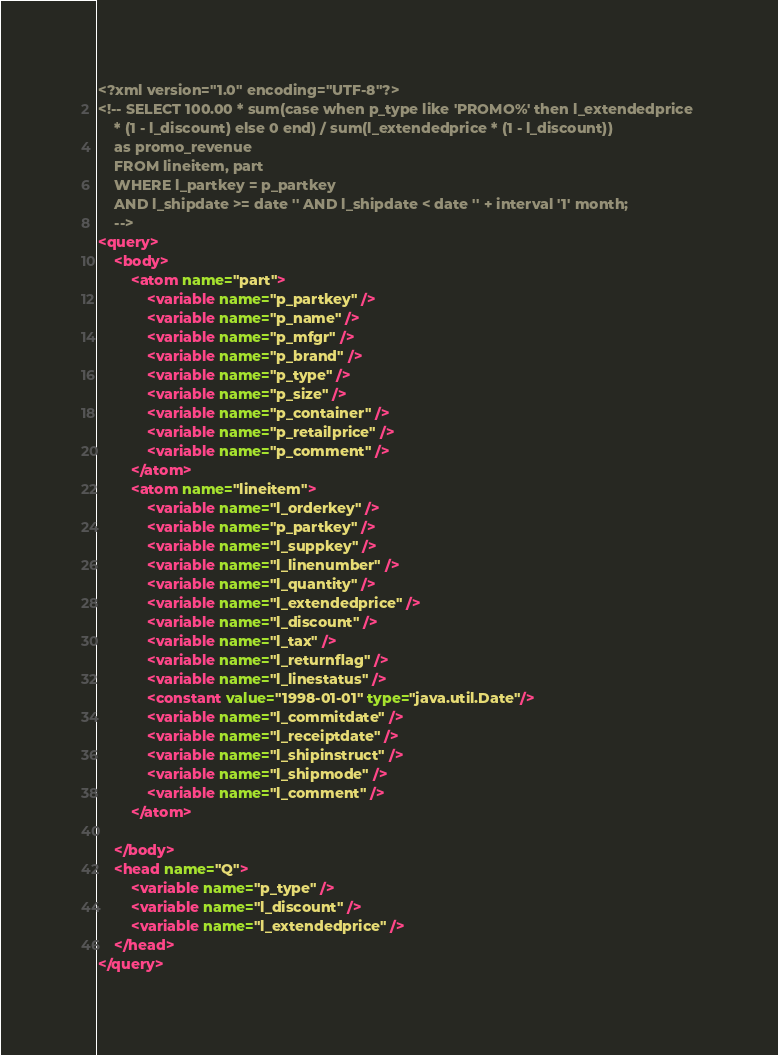<code> <loc_0><loc_0><loc_500><loc_500><_XML_><?xml version="1.0" encoding="UTF-8"?>
<!-- SELECT 100.00 * sum(case when p_type like 'PROMO%' then l_extendedprice 
	* (1 - l_discount) else 0 end) / sum(l_extendedprice * (1 - l_discount)) 
	as promo_revenue 
	FROM lineitem, part 
	WHERE l_partkey = p_partkey
	AND l_shipdate >= date '' AND l_shipdate < date '' + interval '1' month;
	-->
<query>
	<body>
		<atom name="part">
			<variable name="p_partkey" />
			<variable name="p_name" />
			<variable name="p_mfgr" />
			<variable name="p_brand" />
			<variable name="p_type" />
			<variable name="p_size" />
			<variable name="p_container" />
			<variable name="p_retailprice" />
			<variable name="p_comment" />
		</atom>
		<atom name="lineitem">
			<variable name="l_orderkey" />
			<variable name="p_partkey" />
			<variable name="l_suppkey" />
			<variable name="l_linenumber" />
			<variable name="l_quantity" />
			<variable name="l_extendedprice" />
			<variable name="l_discount" />
			<variable name="l_tax" />
			<variable name="l_returnflag" />
			<variable name="l_linestatus" />
			<constant value="1998-01-01" type="java.util.Date"/>
			<variable name="l_commitdate" />
			<variable name="l_receiptdate" />
			<variable name="l_shipinstruct" />
			<variable name="l_shipmode" />
			<variable name="l_comment" />
		</atom>

	</body>
	<head name="Q">
		<variable name="p_type" />
		<variable name="l_discount" />
		<variable name="l_extendedprice" />
	</head>
</query>
</code> 